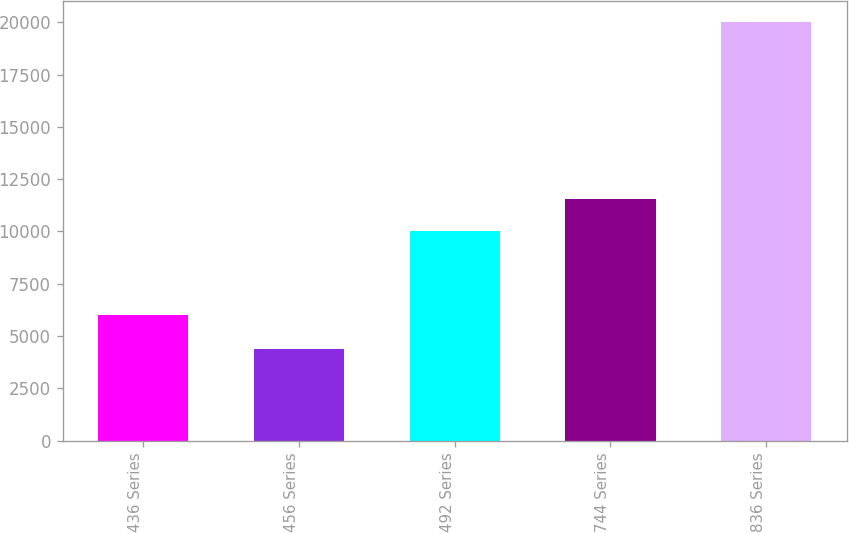<chart> <loc_0><loc_0><loc_500><loc_500><bar_chart><fcel>436 Series<fcel>456 Series<fcel>492 Series<fcel>744 Series<fcel>836 Series<nl><fcel>5992<fcel>4389<fcel>10000<fcel>11561.1<fcel>20000<nl></chart> 